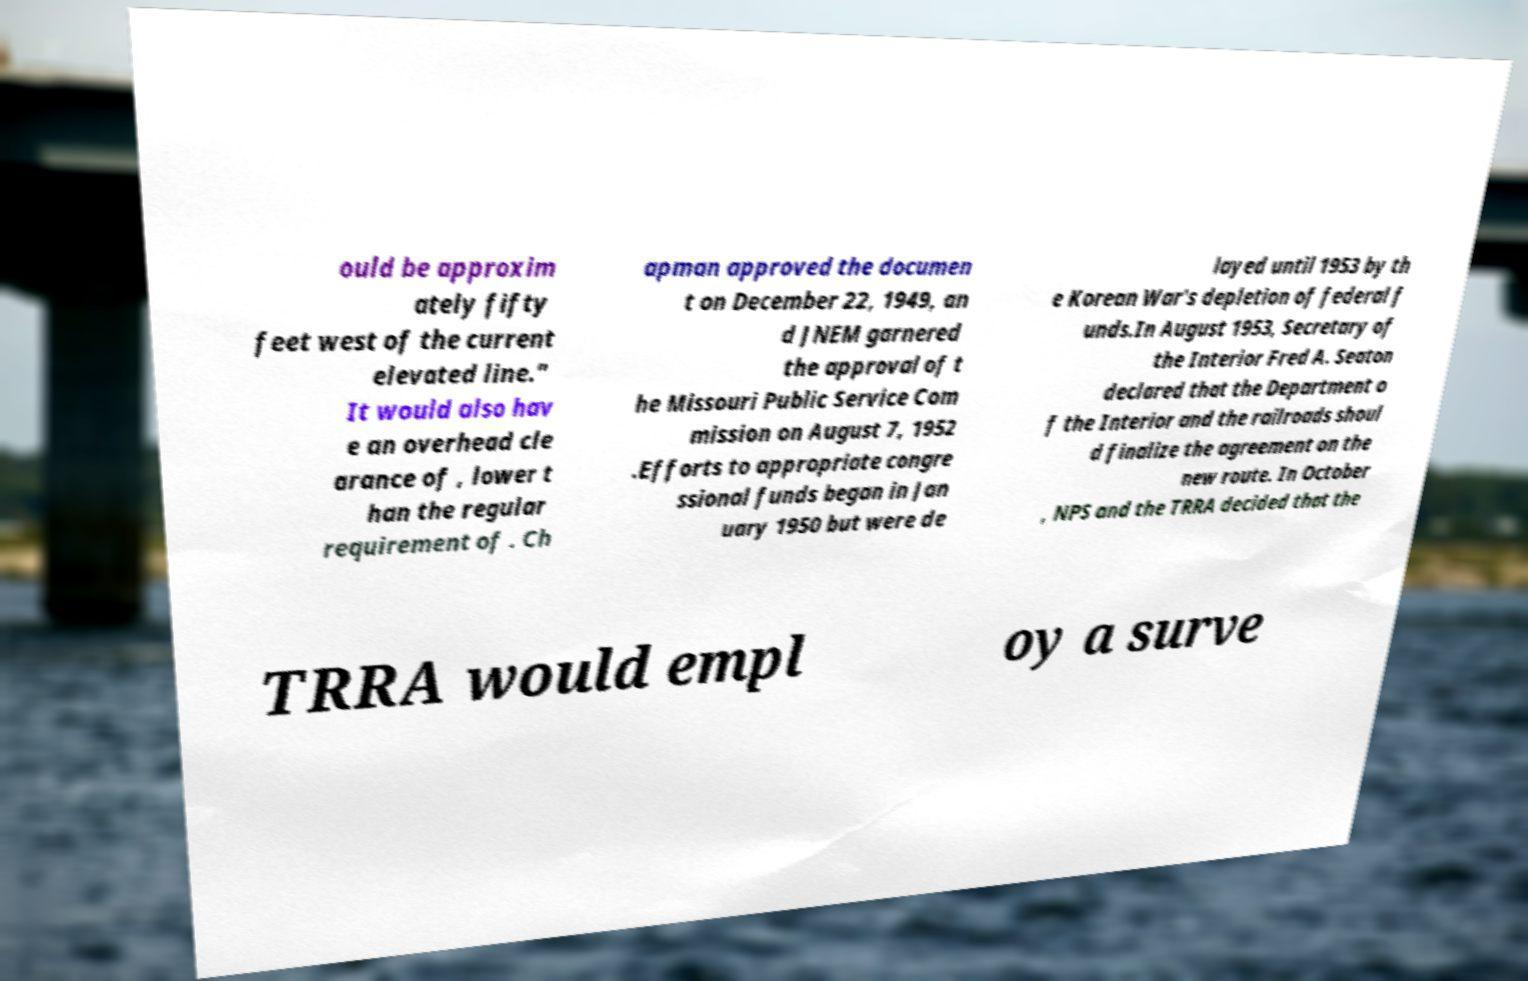What messages or text are displayed in this image? I need them in a readable, typed format. ould be approxim ately fifty feet west of the current elevated line." It would also hav e an overhead cle arance of , lower t han the regular requirement of . Ch apman approved the documen t on December 22, 1949, an d JNEM garnered the approval of t he Missouri Public Service Com mission on August 7, 1952 .Efforts to appropriate congre ssional funds began in Jan uary 1950 but were de layed until 1953 by th e Korean War's depletion of federal f unds.In August 1953, Secretary of the Interior Fred A. Seaton declared that the Department o f the Interior and the railroads shoul d finalize the agreement on the new route. In October , NPS and the TRRA decided that the TRRA would empl oy a surve 